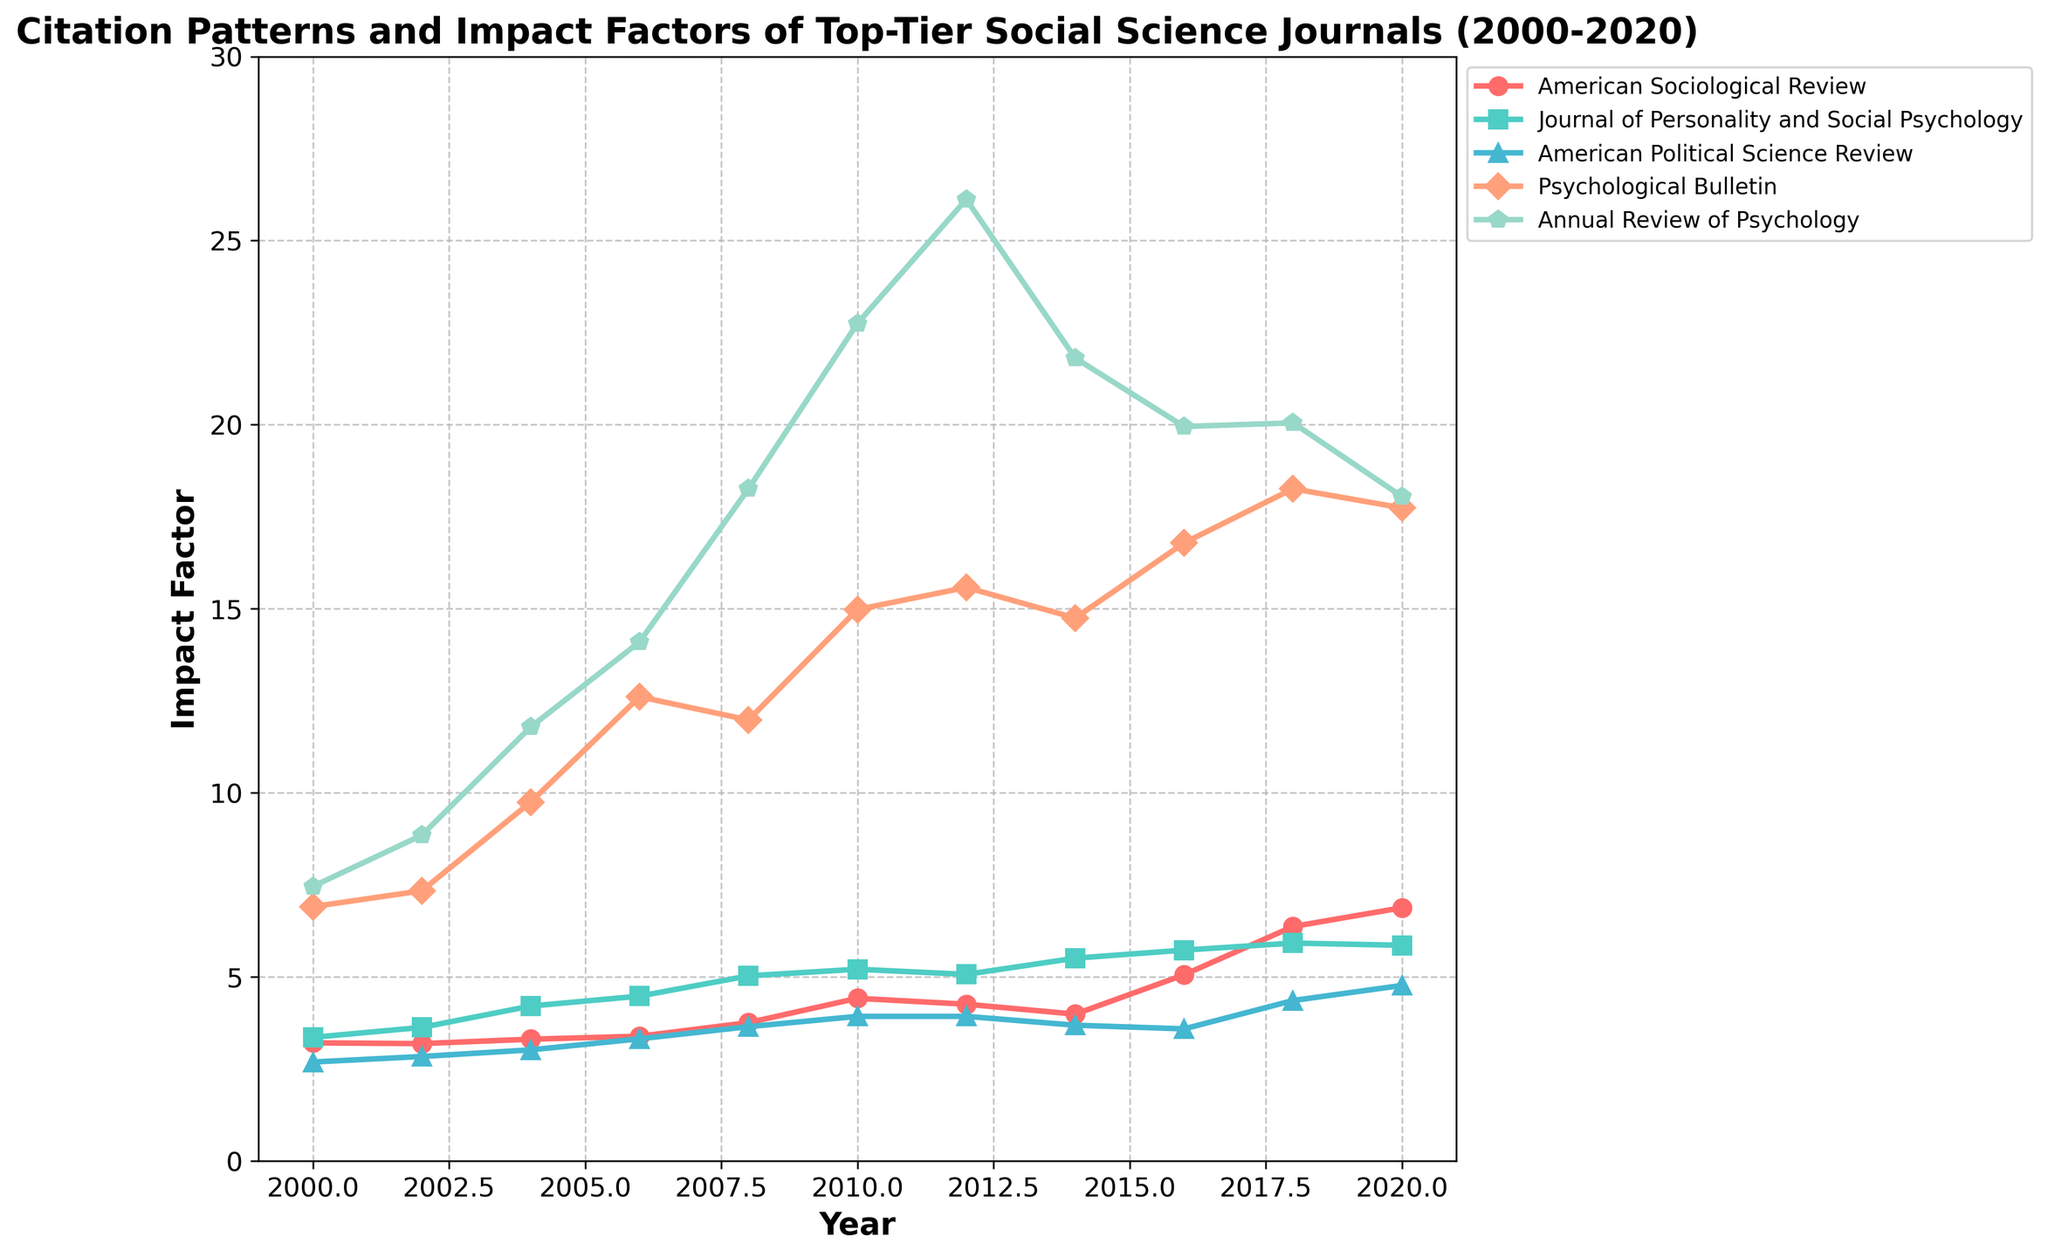What is the general trend in the impact factor of the American Sociological Review from 2000 to 2020? To determine the general trend, observe the line representing the American Sociological Review from 2000 to 2020. The impact factor starts at 3.21 in 2000 and increases to 6.88 in 2020, showing a general upward trend with small fluctuations.
Answer: Upward trend Which journal had the highest impact factor in 2010? Look at the impact factors for all journals in the year 2010 and compare them. The Psychological Bulletin has the highest impact factor with 14.98.
Answer: Psychological Bulletin By how much did the impact factor of the Annual Review of Psychology change from 2004 to 2010? Check the impact factor values of the Annual Review of Psychology in 2004 (11.79) and in 2010 (22.75) and calculate the difference: 22.75 - 11.79 = 10.96.
Answer: 10.96 Between 2016 and 2020, which journal experienced a decline in impact factor? Compare the impact factors of the journals in 2016 and 2020. The Annual Review of Psychology's impact factor decreased from 19.95 in 2016 to 18.05 in 2020.
Answer: Annual Review of Psychology What is the average impact factor of Psychological Bulletin from 2000 to 2020? Sum the impact factors of Psychological Bulletin for all the years provided and divide by the number of years: (6.91 + 7.34 + 9.75 + 12.61 + 11.98 + 14.98 + 15.58 + 14.75 + 16.79 + 18.26 + 17.74) / 11 ≈ 13.21.
Answer: 13.21 In which year did the Journal of Personality and Social Psychology have the highest impact factor, and what was it? Find the peak value for the Journal of Personality and Social Psychology on the plot and note its corresponding year. The highest value is 5.92 in 2018.
Answer: 2018, 5.92 How much higher was the impact factor of the American Political Science Review in 2020 compared to 2000? Subtract the impact factor in 2000 (2.69) from the impact factor in 2020 (4.77): 4.77 - 2.69 = 2.08.
Answer: 2.08 Which journal showed the most significant growth in the impact factor between 2000 and 2020? Look at the overall change in impact factors from 2000 to 2020 for all journals. The Annual Review of Psychology increased from 7.46 in 2000 to 18.05 in 2020, a change of 10.59, which is the largest.
Answer: Annual Review of Psychology What is the most notable pattern in the data for the Annual Review of Psychology between 2004 and 2012? Observe the impact factor changes for the Annual Review of Psychology from 2004 (11.79) to 2012 (26.12). The impact factor increases consistently with notable growth, reaching its peak in 2012.
Answer: Consistent increase Which journal had a higher impact factor in 2006: American Sociological Review or Journal of Personality and Social Psychology? Compare the impact factors in 2006 for the two journals. The American Sociological Review is 3.39, and the Journal of Personality and Social Psychology is 4.48, which is higher.
Answer: Journal of Personality and Social Psychology 